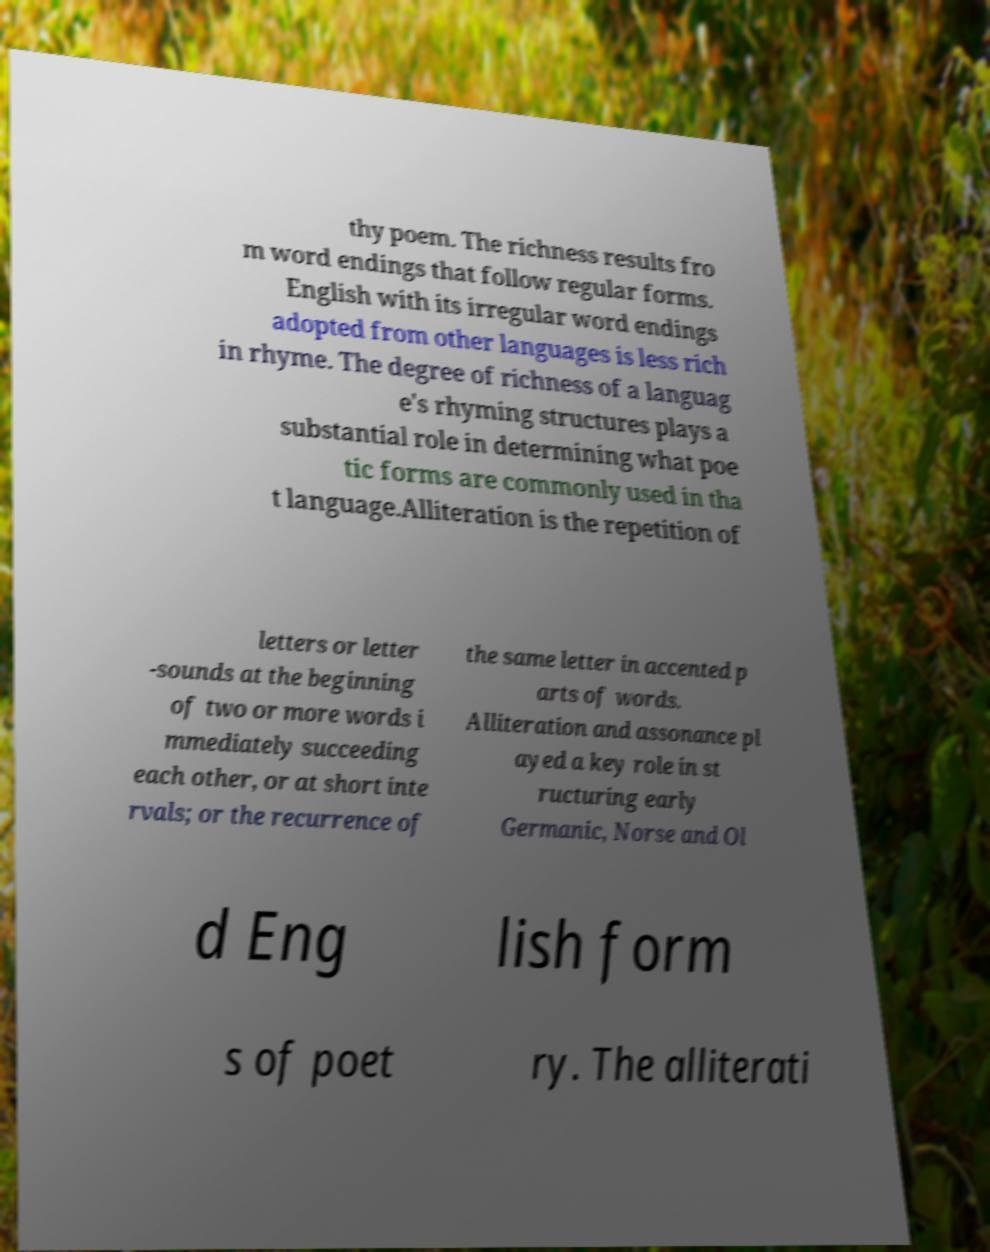What messages or text are displayed in this image? I need them in a readable, typed format. thy poem. The richness results fro m word endings that follow regular forms. English with its irregular word endings adopted from other languages is less rich in rhyme. The degree of richness of a languag e's rhyming structures plays a substantial role in determining what poe tic forms are commonly used in tha t language.Alliteration is the repetition of letters or letter -sounds at the beginning of two or more words i mmediately succeeding each other, or at short inte rvals; or the recurrence of the same letter in accented p arts of words. Alliteration and assonance pl ayed a key role in st ructuring early Germanic, Norse and Ol d Eng lish form s of poet ry. The alliterati 